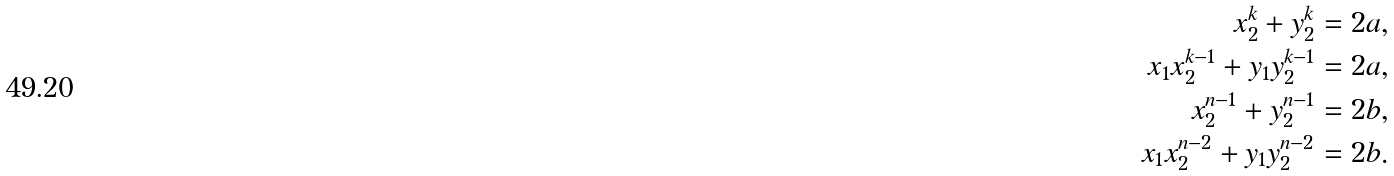Convert formula to latex. <formula><loc_0><loc_0><loc_500><loc_500>x _ { 2 } ^ { k } + y _ { 2 } ^ { k } & = 2 a , \\ x _ { 1 } x _ { 2 } ^ { k - 1 } + y _ { 1 } y _ { 2 } ^ { k - 1 } & = 2 a , \\ x _ { 2 } ^ { n - 1 } + y _ { 2 } ^ { n - 1 } & = 2 b , \\ x _ { 1 } x _ { 2 } ^ { n - 2 } + y _ { 1 } y _ { 2 } ^ { n - 2 } & = 2 b .</formula> 